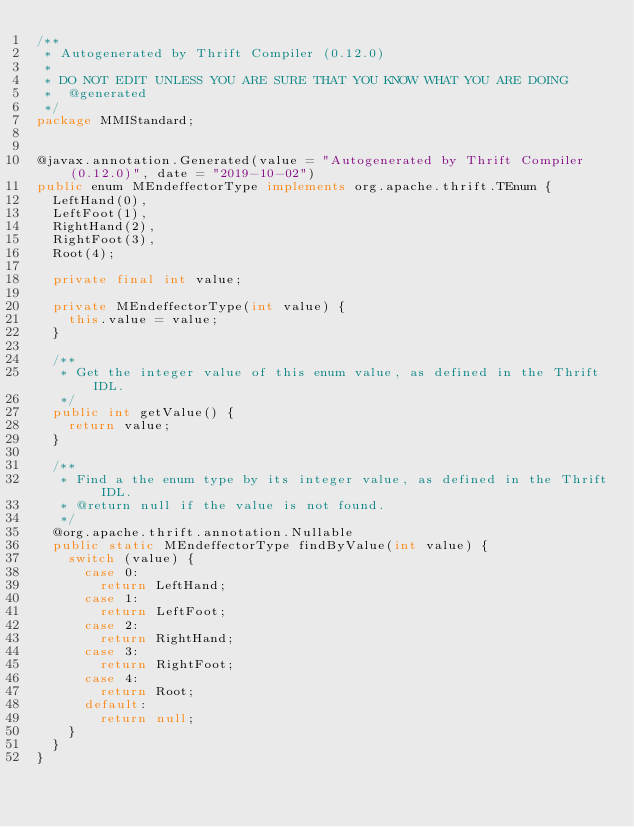Convert code to text. <code><loc_0><loc_0><loc_500><loc_500><_Java_>/**
 * Autogenerated by Thrift Compiler (0.12.0)
 *
 * DO NOT EDIT UNLESS YOU ARE SURE THAT YOU KNOW WHAT YOU ARE DOING
 *  @generated
 */
package MMIStandard;


@javax.annotation.Generated(value = "Autogenerated by Thrift Compiler (0.12.0)", date = "2019-10-02")
public enum MEndeffectorType implements org.apache.thrift.TEnum {
  LeftHand(0),
  LeftFoot(1),
  RightHand(2),
  RightFoot(3),
  Root(4);

  private final int value;

  private MEndeffectorType(int value) {
    this.value = value;
  }

  /**
   * Get the integer value of this enum value, as defined in the Thrift IDL.
   */
  public int getValue() {
    return value;
  }

  /**
   * Find a the enum type by its integer value, as defined in the Thrift IDL.
   * @return null if the value is not found.
   */
  @org.apache.thrift.annotation.Nullable
  public static MEndeffectorType findByValue(int value) { 
    switch (value) {
      case 0:
        return LeftHand;
      case 1:
        return LeftFoot;
      case 2:
        return RightHand;
      case 3:
        return RightFoot;
      case 4:
        return Root;
      default:
        return null;
    }
  }
}
</code> 